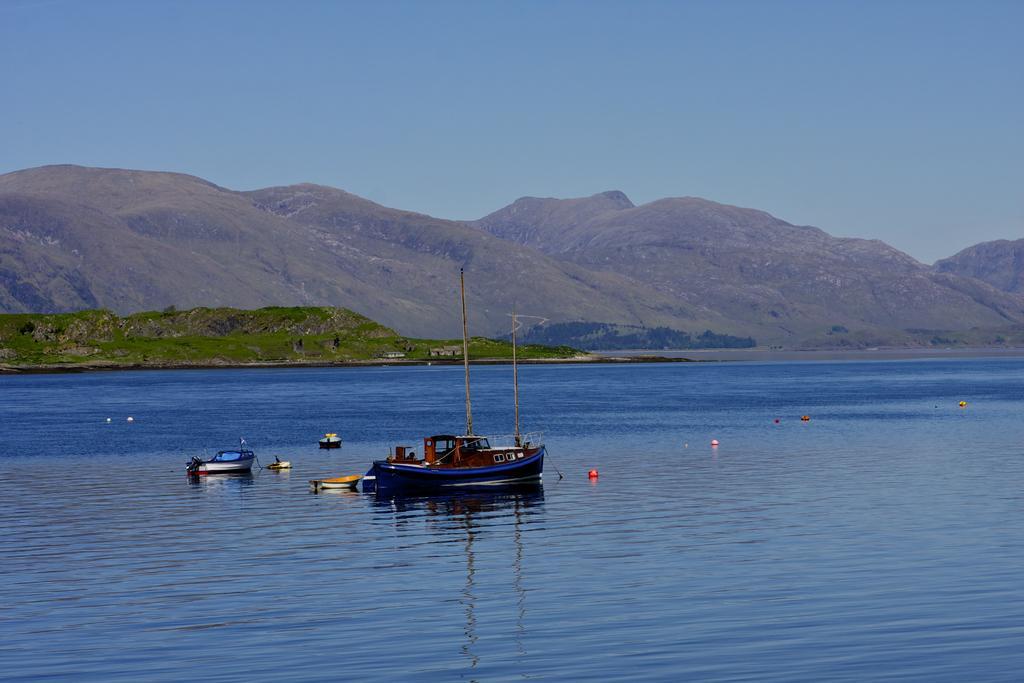Please provide a concise description of this image. This picture is clicked outside the city. In the center we can see the boats and some other objects in the water body. In the background we can see the sky and the hills and the green grass and some other objects. 